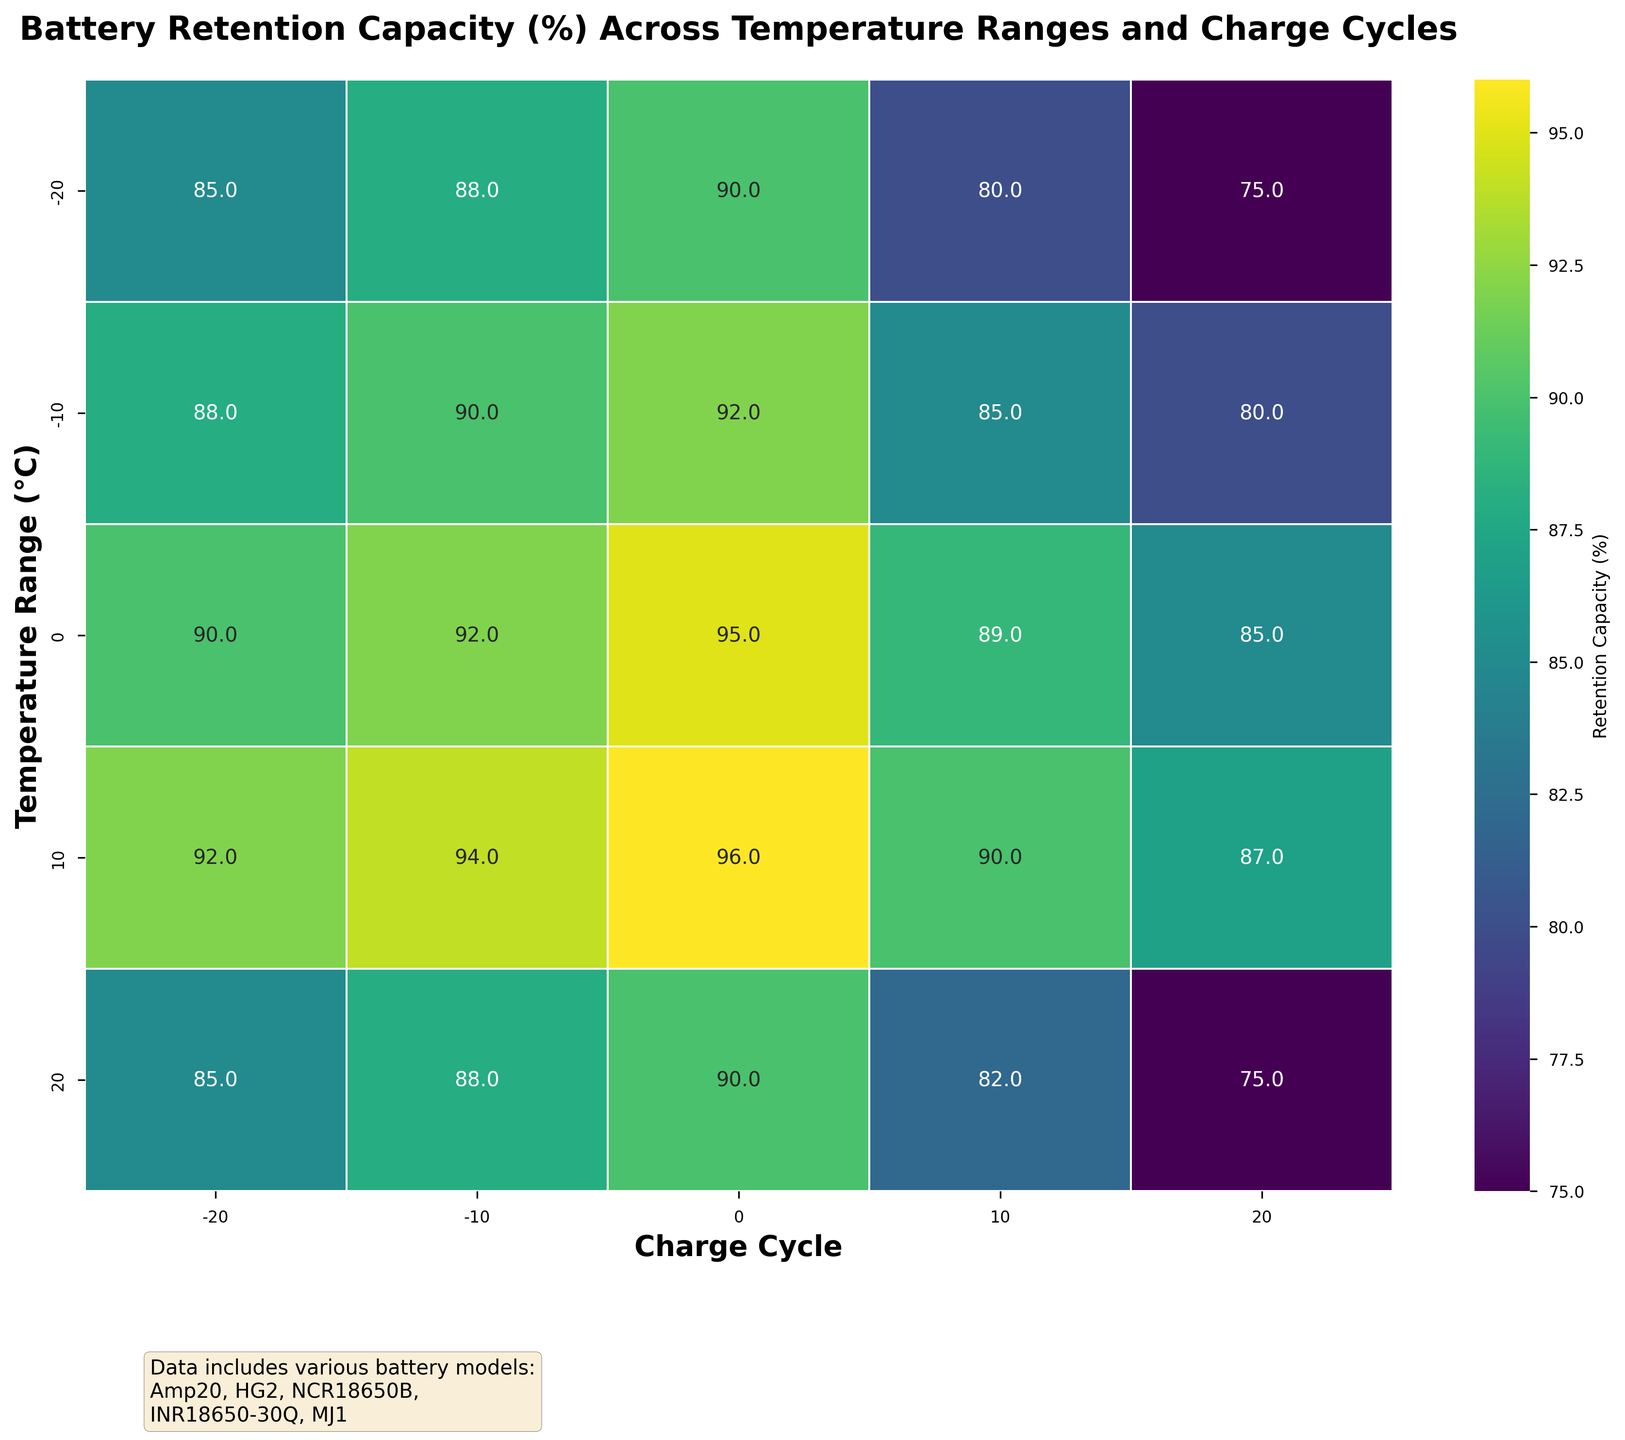What is the title of the figure? The title is typically placed at the top of the figure, and this one states the main topic being illustrated by the heatmap.
Answer: Battery Retention Capacity (%) Across Temperature Ranges and Charge Cycles What is the x-axis label? The x-axis label provides information about what the horizontal axis represents. In this case, it would be related to the charge cycle of batteries.
Answer: Charge Cycle What is the y-axis label? The y-axis label provides information about what the vertical axis represents. In this heatmap, it indicates the temperature range.
Answer: Temperature Range (°C) What color represents the highest retention capacity percentage on the heatmap? To answer this, you need to look at the color scale (usually provided by the color bar) and identify the color associated with the highest number.
Answer: Bright yellowish-green Which temperature range and charge cycle combination has the lowest retention capacity? By inspecting the heatmap and identifying the lowest annotated value, you can determine the specific combination.
Answer: 20°C and 20 cycles What's the overall pattern of retention capacity as temperature increases? Observing the color gradient vertically (temperature axis), you need to describe how retention capacity changes with temperature.
Answer: Generally decreases How does the retention capacity at 0°C compare between -20 and 20 charge cycles? This requires comparing the values at 0°C for charge cycles -20 and 20.
Answer: Retention capacity is 90% at -20 cycles and 85% at 20 cycles Which charge cycle shows the highest retention capacity at 10°C? By examining the data row corresponding to 10°C, identify the charge cycle with the highest value.
Answer: 0 charge cycles Compare retention capacity between -20°C and 0°C at 0 charge cycles. Look at the values for -20°C and 0°C within the 0 charge cycle column and compare them.
Answer: 90% for both How does retention capacity at -20°C and -10°C change from -20 to 20 charge cycles? Analyze the values moving horizontally across from -20 to 20 charge cycles for both -20°C and -10°C rows.
Answer: Decreases from 85% to 75% at -20°C and from 88% to 80% at -10°C 